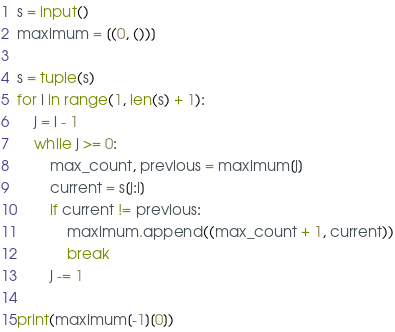Convert code to text. <code><loc_0><loc_0><loc_500><loc_500><_Python_>s = input()
maximum = [(0, ())]

s = tuple(s)
for i in range(1, len(s) + 1):
    j = i - 1
    while j >= 0:
        max_count, previous = maximum[j]
        current = s[j:i]
        if current != previous:
            maximum.append((max_count + 1, current))
            break
        j -= 1

print(maximum[-1][0])</code> 